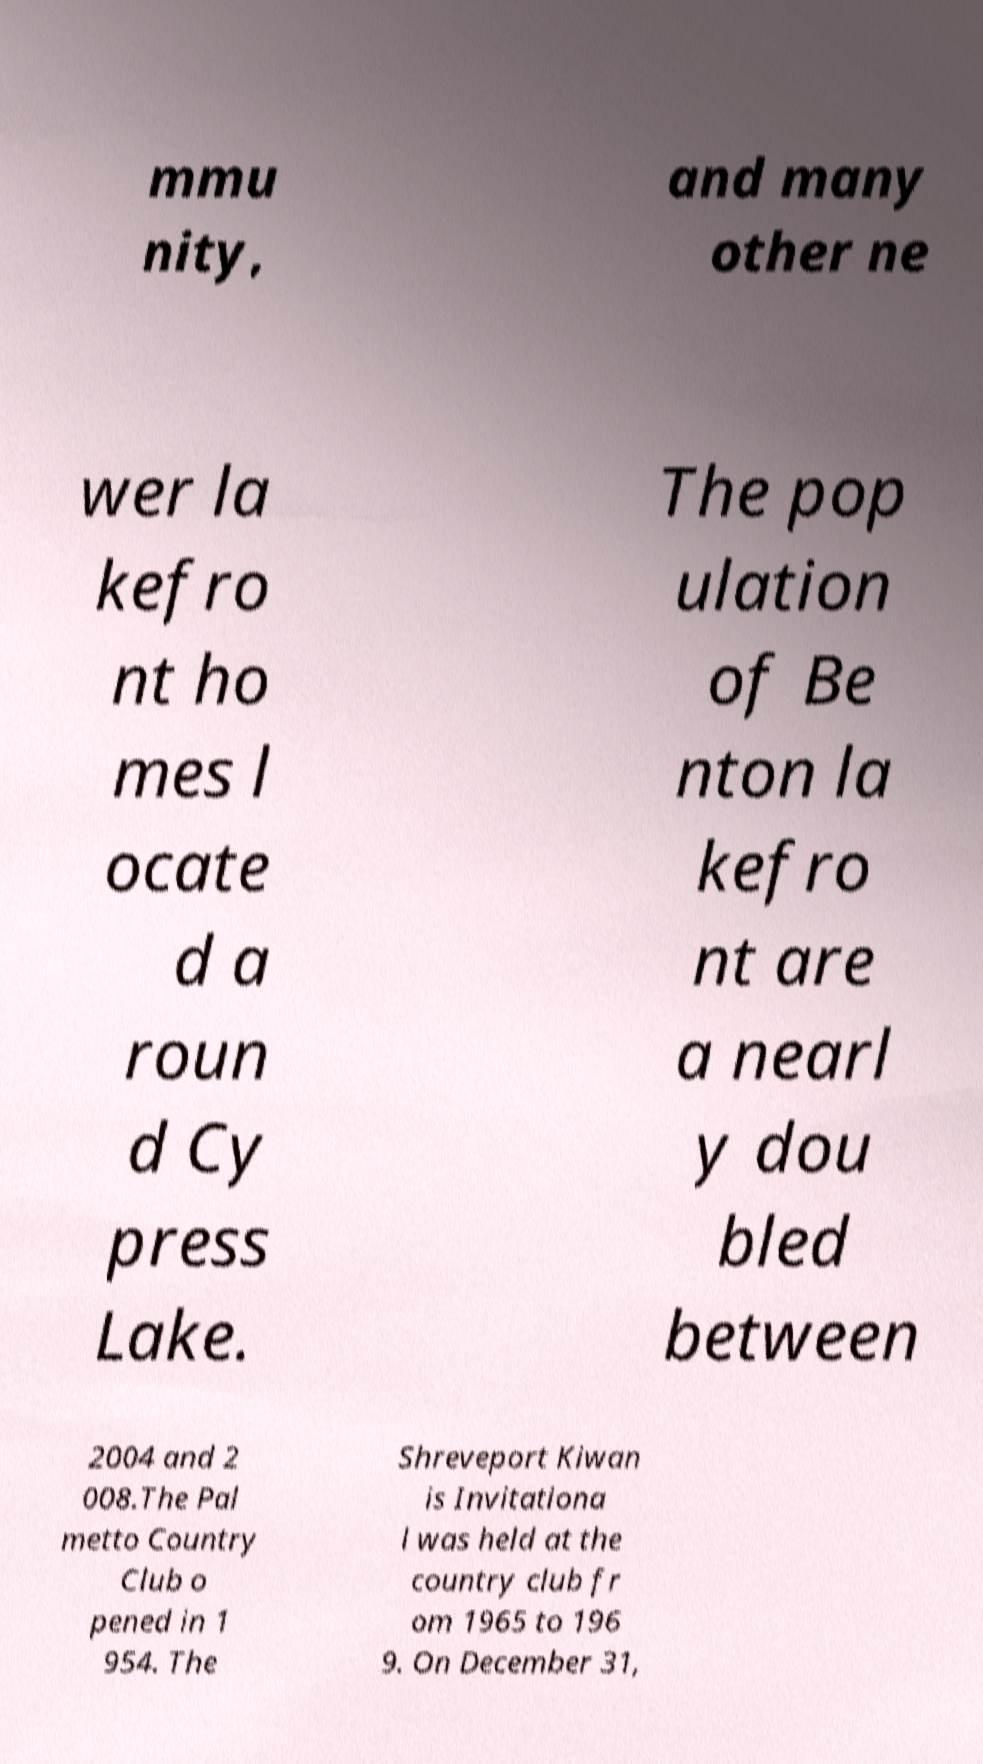Please identify and transcribe the text found in this image. mmu nity, and many other ne wer la kefro nt ho mes l ocate d a roun d Cy press Lake. The pop ulation of Be nton la kefro nt are a nearl y dou bled between 2004 and 2 008.The Pal metto Country Club o pened in 1 954. The Shreveport Kiwan is Invitationa l was held at the country club fr om 1965 to 196 9. On December 31, 